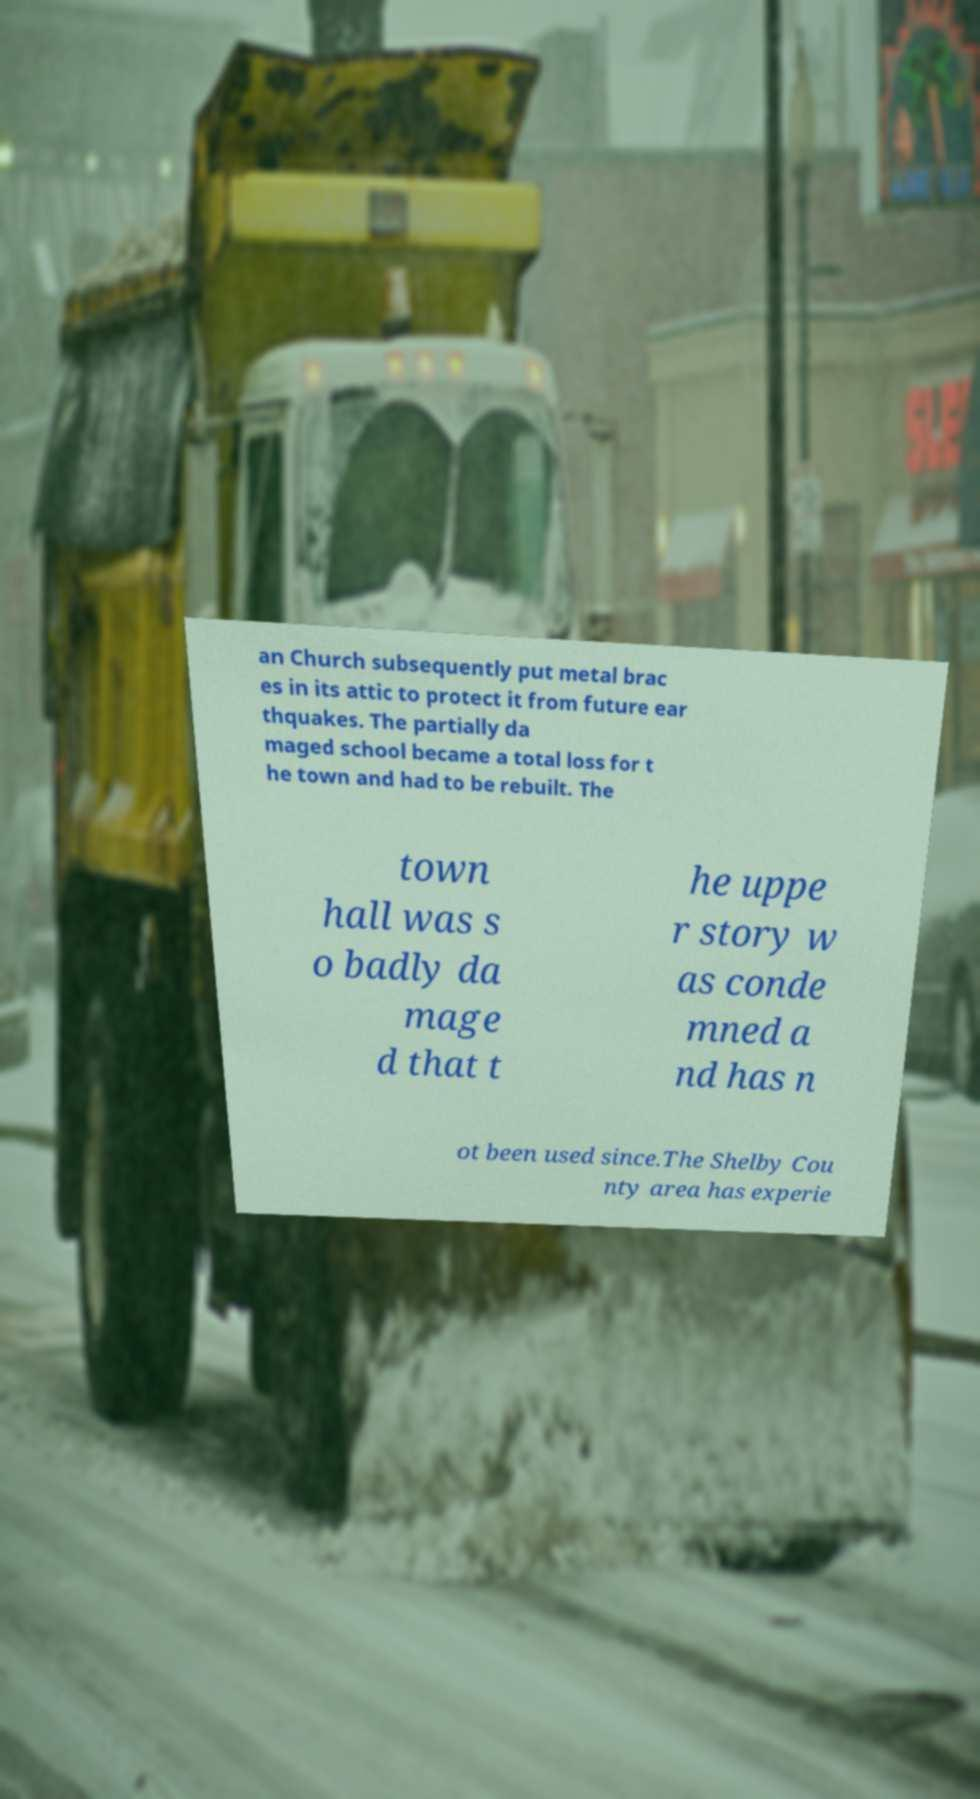Could you extract and type out the text from this image? an Church subsequently put metal brac es in its attic to protect it from future ear thquakes. The partially da maged school became a total loss for t he town and had to be rebuilt. The town hall was s o badly da mage d that t he uppe r story w as conde mned a nd has n ot been used since.The Shelby Cou nty area has experie 